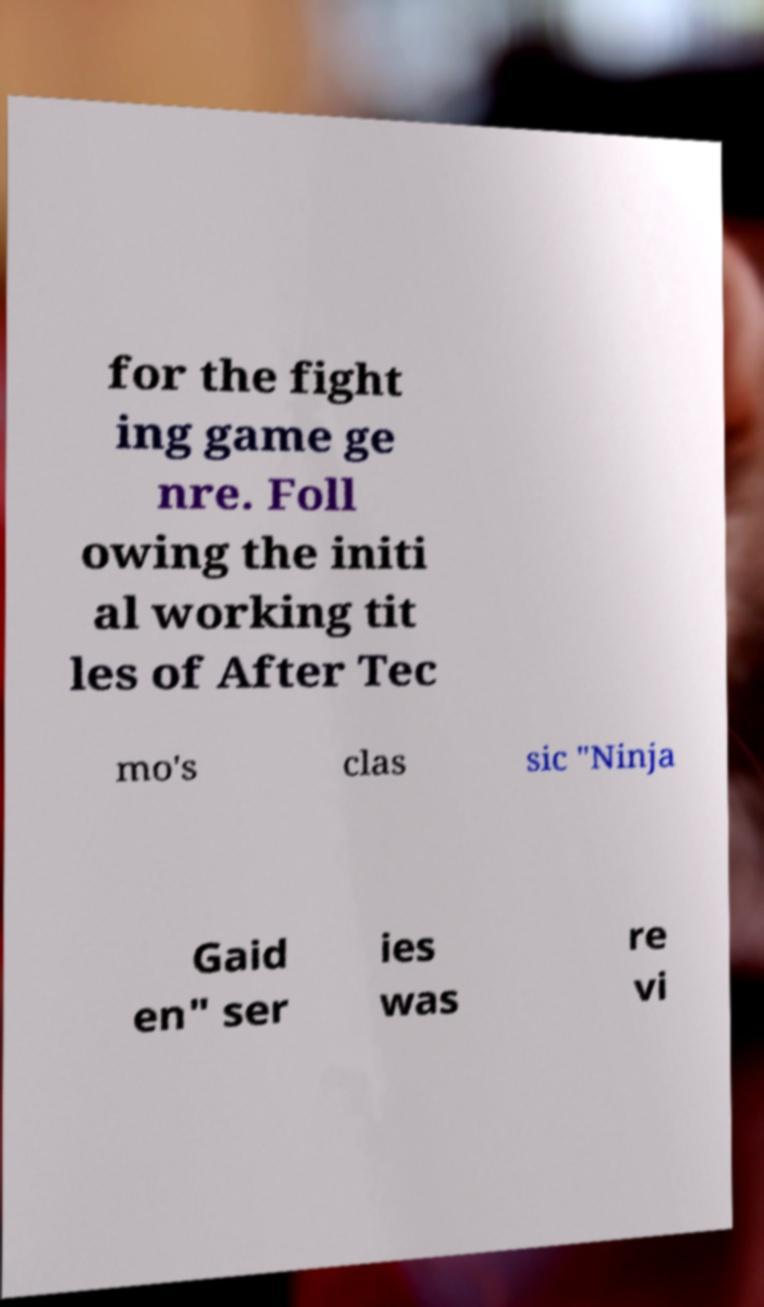Can you accurately transcribe the text from the provided image for me? for the fight ing game ge nre. Foll owing the initi al working tit les of After Tec mo's clas sic "Ninja Gaid en" ser ies was re vi 